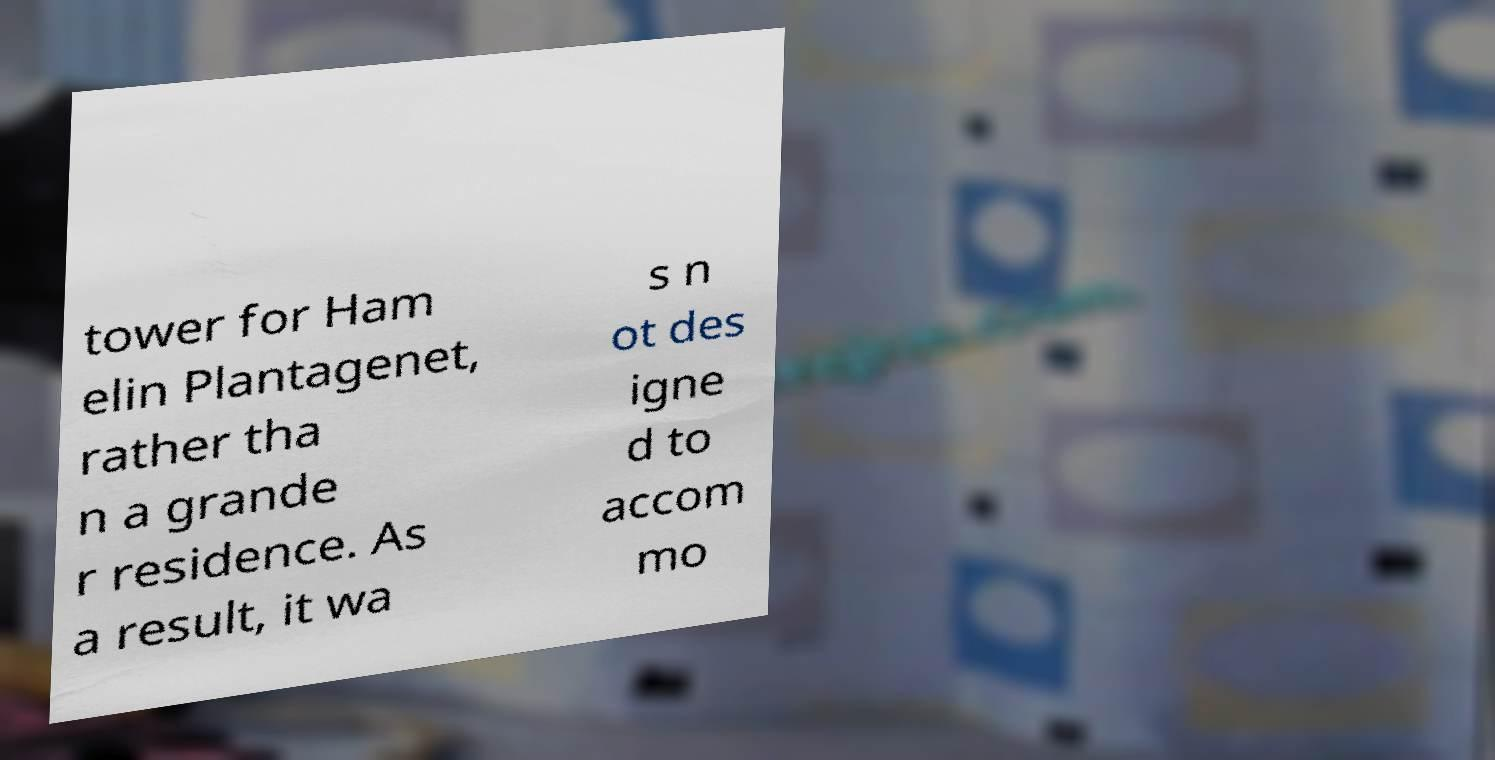For documentation purposes, I need the text within this image transcribed. Could you provide that? tower for Ham elin Plantagenet, rather tha n a grande r residence. As a result, it wa s n ot des igne d to accom mo 